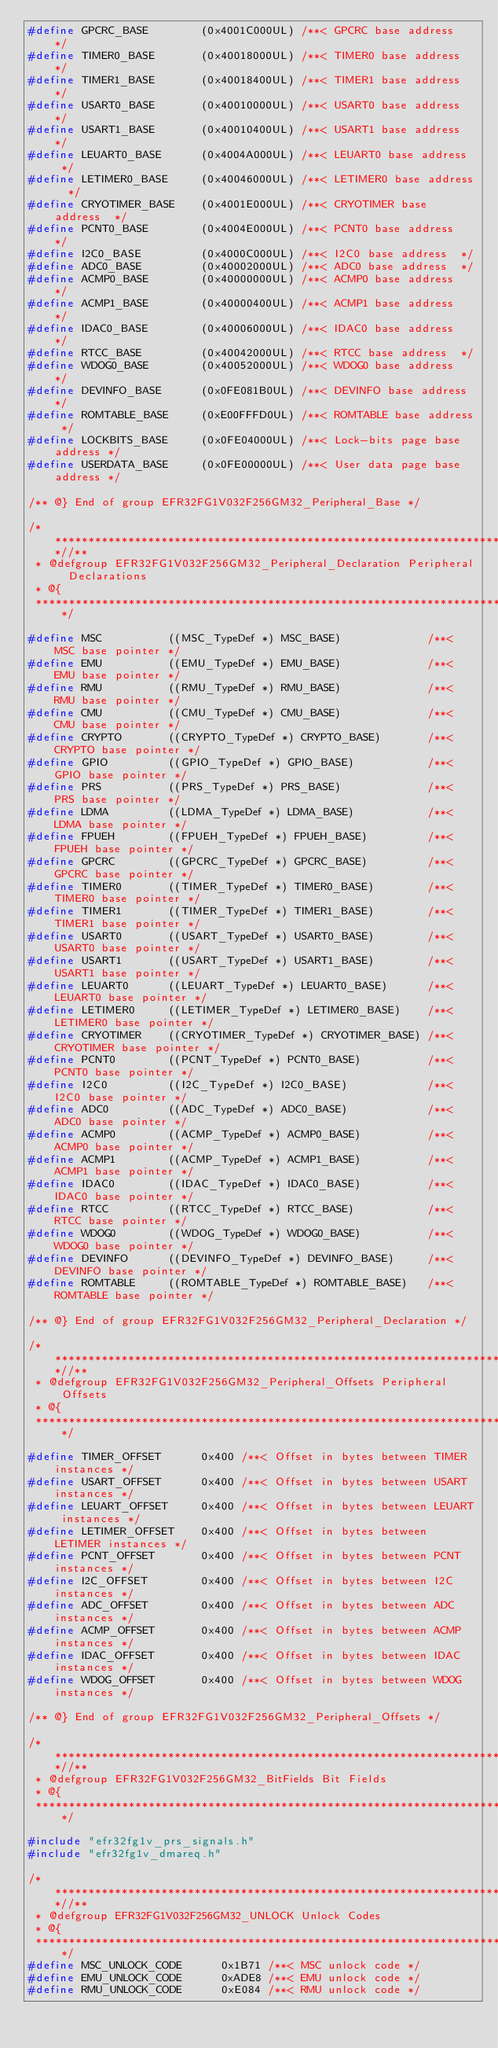<code> <loc_0><loc_0><loc_500><loc_500><_C_>#define GPCRC_BASE        (0x4001C000UL) /**< GPCRC base address  */
#define TIMER0_BASE       (0x40018000UL) /**< TIMER0 base address  */
#define TIMER1_BASE       (0x40018400UL) /**< TIMER1 base address  */
#define USART0_BASE       (0x40010000UL) /**< USART0 base address  */
#define USART1_BASE       (0x40010400UL) /**< USART1 base address  */
#define LEUART0_BASE      (0x4004A000UL) /**< LEUART0 base address  */
#define LETIMER0_BASE     (0x40046000UL) /**< LETIMER0 base address  */
#define CRYOTIMER_BASE    (0x4001E000UL) /**< CRYOTIMER base address  */
#define PCNT0_BASE        (0x4004E000UL) /**< PCNT0 base address  */
#define I2C0_BASE         (0x4000C000UL) /**< I2C0 base address  */
#define ADC0_BASE         (0x40002000UL) /**< ADC0 base address  */
#define ACMP0_BASE        (0x40000000UL) /**< ACMP0 base address  */
#define ACMP1_BASE        (0x40000400UL) /**< ACMP1 base address  */
#define IDAC0_BASE        (0x40006000UL) /**< IDAC0 base address  */
#define RTCC_BASE         (0x40042000UL) /**< RTCC base address  */
#define WDOG0_BASE        (0x40052000UL) /**< WDOG0 base address  */
#define DEVINFO_BASE      (0x0FE081B0UL) /**< DEVINFO base address */
#define ROMTABLE_BASE     (0xE00FFFD0UL) /**< ROMTABLE base address */
#define LOCKBITS_BASE     (0x0FE04000UL) /**< Lock-bits page base address */
#define USERDATA_BASE     (0x0FE00000UL) /**< User data page base address */

/** @} End of group EFR32FG1V032F256GM32_Peripheral_Base */

/**************************************************************************//**
 * @defgroup EFR32FG1V032F256GM32_Peripheral_Declaration Peripheral Declarations
 * @{
 *****************************************************************************/

#define MSC          ((MSC_TypeDef *) MSC_BASE)             /**< MSC base pointer */
#define EMU          ((EMU_TypeDef *) EMU_BASE)             /**< EMU base pointer */
#define RMU          ((RMU_TypeDef *) RMU_BASE)             /**< RMU base pointer */
#define CMU          ((CMU_TypeDef *) CMU_BASE)             /**< CMU base pointer */
#define CRYPTO       ((CRYPTO_TypeDef *) CRYPTO_BASE)       /**< CRYPTO base pointer */
#define GPIO         ((GPIO_TypeDef *) GPIO_BASE)           /**< GPIO base pointer */
#define PRS          ((PRS_TypeDef *) PRS_BASE)             /**< PRS base pointer */
#define LDMA         ((LDMA_TypeDef *) LDMA_BASE)           /**< LDMA base pointer */
#define FPUEH        ((FPUEH_TypeDef *) FPUEH_BASE)         /**< FPUEH base pointer */
#define GPCRC        ((GPCRC_TypeDef *) GPCRC_BASE)         /**< GPCRC base pointer */
#define TIMER0       ((TIMER_TypeDef *) TIMER0_BASE)        /**< TIMER0 base pointer */
#define TIMER1       ((TIMER_TypeDef *) TIMER1_BASE)        /**< TIMER1 base pointer */
#define USART0       ((USART_TypeDef *) USART0_BASE)        /**< USART0 base pointer */
#define USART1       ((USART_TypeDef *) USART1_BASE)        /**< USART1 base pointer */
#define LEUART0      ((LEUART_TypeDef *) LEUART0_BASE)      /**< LEUART0 base pointer */
#define LETIMER0     ((LETIMER_TypeDef *) LETIMER0_BASE)    /**< LETIMER0 base pointer */
#define CRYOTIMER    ((CRYOTIMER_TypeDef *) CRYOTIMER_BASE) /**< CRYOTIMER base pointer */
#define PCNT0        ((PCNT_TypeDef *) PCNT0_BASE)          /**< PCNT0 base pointer */
#define I2C0         ((I2C_TypeDef *) I2C0_BASE)            /**< I2C0 base pointer */
#define ADC0         ((ADC_TypeDef *) ADC0_BASE)            /**< ADC0 base pointer */
#define ACMP0        ((ACMP_TypeDef *) ACMP0_BASE)          /**< ACMP0 base pointer */
#define ACMP1        ((ACMP_TypeDef *) ACMP1_BASE)          /**< ACMP1 base pointer */
#define IDAC0        ((IDAC_TypeDef *) IDAC0_BASE)          /**< IDAC0 base pointer */
#define RTCC         ((RTCC_TypeDef *) RTCC_BASE)           /**< RTCC base pointer */
#define WDOG0        ((WDOG_TypeDef *) WDOG0_BASE)          /**< WDOG0 base pointer */
#define DEVINFO      ((DEVINFO_TypeDef *) DEVINFO_BASE)     /**< DEVINFO base pointer */
#define ROMTABLE     ((ROMTABLE_TypeDef *) ROMTABLE_BASE)   /**< ROMTABLE base pointer */

/** @} End of group EFR32FG1V032F256GM32_Peripheral_Declaration */

/**************************************************************************//**
 * @defgroup EFR32FG1V032F256GM32_Peripheral_Offsets Peripheral Offsets
 * @{
 *****************************************************************************/

#define TIMER_OFFSET      0x400 /**< Offset in bytes between TIMER instances */
#define USART_OFFSET      0x400 /**< Offset in bytes between USART instances */
#define LEUART_OFFSET     0x400 /**< Offset in bytes between LEUART instances */
#define LETIMER_OFFSET    0x400 /**< Offset in bytes between LETIMER instances */
#define PCNT_OFFSET       0x400 /**< Offset in bytes between PCNT instances */
#define I2C_OFFSET        0x400 /**< Offset in bytes between I2C instances */
#define ADC_OFFSET        0x400 /**< Offset in bytes between ADC instances */
#define ACMP_OFFSET       0x400 /**< Offset in bytes between ACMP instances */
#define IDAC_OFFSET       0x400 /**< Offset in bytes between IDAC instances */
#define WDOG_OFFSET       0x400 /**< Offset in bytes between WDOG instances */

/** @} End of group EFR32FG1V032F256GM32_Peripheral_Offsets */

/**************************************************************************//**
 * @defgroup EFR32FG1V032F256GM32_BitFields Bit Fields
 * @{
 *****************************************************************************/

#include "efr32fg1v_prs_signals.h"
#include "efr32fg1v_dmareq.h"

/**************************************************************************//**
 * @defgroup EFR32FG1V032F256GM32_UNLOCK Unlock Codes
 * @{
 *****************************************************************************/
#define MSC_UNLOCK_CODE      0x1B71 /**< MSC unlock code */
#define EMU_UNLOCK_CODE      0xADE8 /**< EMU unlock code */
#define RMU_UNLOCK_CODE      0xE084 /**< RMU unlock code */</code> 